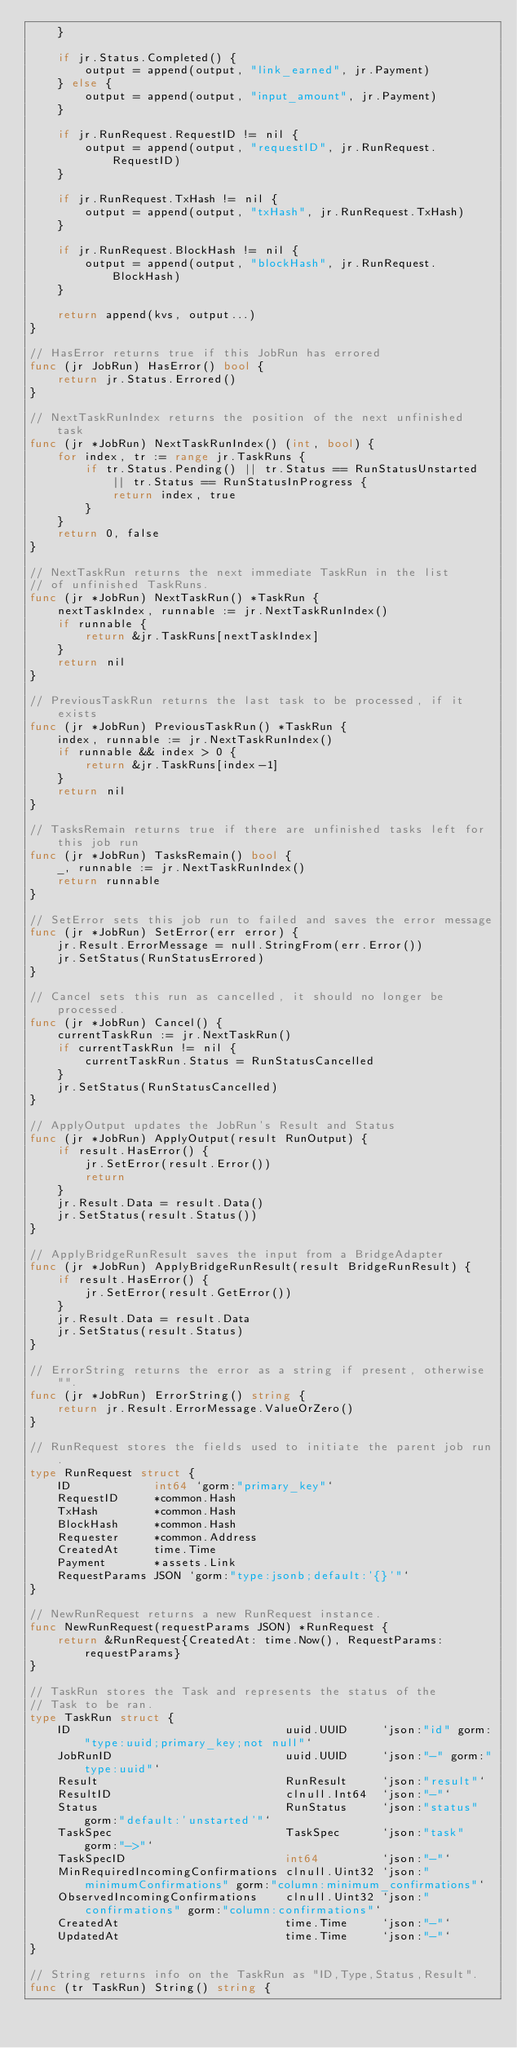<code> <loc_0><loc_0><loc_500><loc_500><_Go_>	}

	if jr.Status.Completed() {
		output = append(output, "link_earned", jr.Payment)
	} else {
		output = append(output, "input_amount", jr.Payment)
	}

	if jr.RunRequest.RequestID != nil {
		output = append(output, "requestID", jr.RunRequest.RequestID)
	}

	if jr.RunRequest.TxHash != nil {
		output = append(output, "txHash", jr.RunRequest.TxHash)
	}

	if jr.RunRequest.BlockHash != nil {
		output = append(output, "blockHash", jr.RunRequest.BlockHash)
	}

	return append(kvs, output...)
}

// HasError returns true if this JobRun has errored
func (jr JobRun) HasError() bool {
	return jr.Status.Errored()
}

// NextTaskRunIndex returns the position of the next unfinished task
func (jr *JobRun) NextTaskRunIndex() (int, bool) {
	for index, tr := range jr.TaskRuns {
		if tr.Status.Pending() || tr.Status == RunStatusUnstarted || tr.Status == RunStatusInProgress {
			return index, true
		}
	}
	return 0, false
}

// NextTaskRun returns the next immediate TaskRun in the list
// of unfinished TaskRuns.
func (jr *JobRun) NextTaskRun() *TaskRun {
	nextTaskIndex, runnable := jr.NextTaskRunIndex()
	if runnable {
		return &jr.TaskRuns[nextTaskIndex]
	}
	return nil
}

// PreviousTaskRun returns the last task to be processed, if it exists
func (jr *JobRun) PreviousTaskRun() *TaskRun {
	index, runnable := jr.NextTaskRunIndex()
	if runnable && index > 0 {
		return &jr.TaskRuns[index-1]
	}
	return nil
}

// TasksRemain returns true if there are unfinished tasks left for this job run
func (jr *JobRun) TasksRemain() bool {
	_, runnable := jr.NextTaskRunIndex()
	return runnable
}

// SetError sets this job run to failed and saves the error message
func (jr *JobRun) SetError(err error) {
	jr.Result.ErrorMessage = null.StringFrom(err.Error())
	jr.SetStatus(RunStatusErrored)
}

// Cancel sets this run as cancelled, it should no longer be processed.
func (jr *JobRun) Cancel() {
	currentTaskRun := jr.NextTaskRun()
	if currentTaskRun != nil {
		currentTaskRun.Status = RunStatusCancelled
	}
	jr.SetStatus(RunStatusCancelled)
}

// ApplyOutput updates the JobRun's Result and Status
func (jr *JobRun) ApplyOutput(result RunOutput) {
	if result.HasError() {
		jr.SetError(result.Error())
		return
	}
	jr.Result.Data = result.Data()
	jr.SetStatus(result.Status())
}

// ApplyBridgeRunResult saves the input from a BridgeAdapter
func (jr *JobRun) ApplyBridgeRunResult(result BridgeRunResult) {
	if result.HasError() {
		jr.SetError(result.GetError())
	}
	jr.Result.Data = result.Data
	jr.SetStatus(result.Status)
}

// ErrorString returns the error as a string if present, otherwise "".
func (jr *JobRun) ErrorString() string {
	return jr.Result.ErrorMessage.ValueOrZero()
}

// RunRequest stores the fields used to initiate the parent job run.
type RunRequest struct {
	ID            int64 `gorm:"primary_key"`
	RequestID     *common.Hash
	TxHash        *common.Hash
	BlockHash     *common.Hash
	Requester     *common.Address
	CreatedAt     time.Time
	Payment       *assets.Link
	RequestParams JSON `gorm:"type:jsonb;default:'{}'"`
}

// NewRunRequest returns a new RunRequest instance.
func NewRunRequest(requestParams JSON) *RunRequest {
	return &RunRequest{CreatedAt: time.Now(), RequestParams: requestParams}
}

// TaskRun stores the Task and represents the status of the
// Task to be ran.
type TaskRun struct {
	ID                               uuid.UUID     `json:"id" gorm:"type:uuid;primary_key;not null"`
	JobRunID                         uuid.UUID     `json:"-" gorm:"type:uuid"`
	Result                           RunResult     `json:"result"`
	ResultID                         clnull.Int64  `json:"-"`
	Status                           RunStatus     `json:"status" gorm:"default:'unstarted'"`
	TaskSpec                         TaskSpec      `json:"task" gorm:"->"`
	TaskSpecID                       int64         `json:"-"`
	MinRequiredIncomingConfirmations clnull.Uint32 `json:"minimumConfirmations" gorm:"column:minimum_confirmations"`
	ObservedIncomingConfirmations    clnull.Uint32 `json:"confirmations" gorm:"column:confirmations"`
	CreatedAt                        time.Time     `json:"-"`
	UpdatedAt                        time.Time     `json:"-"`
}

// String returns info on the TaskRun as "ID,Type,Status,Result".
func (tr TaskRun) String() string {</code> 